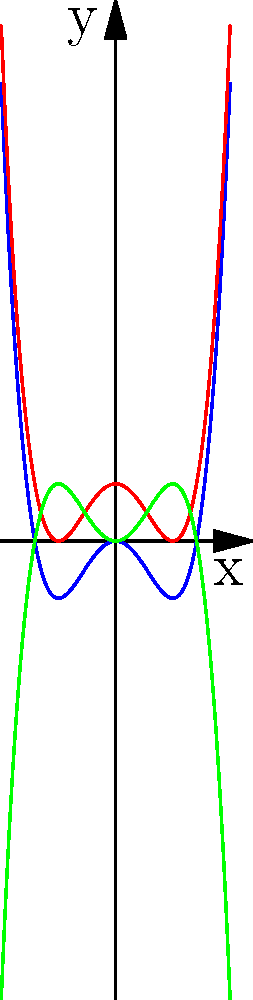As an NLP developer working on language models, you're exploring mathematical concepts to enhance your model's understanding. Consider the quartic polynomial $f(x) = x^4 - 2x^2$ and its transformations $g(x) = x^4 - 2x^2 + 1$ and $h(x) = -x^4 + 2x^2$. How do these transformations affect the graph's key features, such as y-intercepts, local extrema, and end behavior? Describe the changes in relation to the original function $f(x)$. Let's analyze each function step-by-step:

1. Original function $f(x) = x^4 - 2x^2$:
   - Y-intercept: $f(0) = 0$
   - Local extrema: Minimum at $(0,0)$, local maxima at $(\pm 1, -1)$
   - End behavior: As $x \to \pm\infty$, $f(x) \to +\infty$

2. Vertical shift $g(x) = x^4 - 2x^2 + 1$:
   - Y-intercept: $g(0) = 1$ (shifted up by 1 unit)
   - Local extrema: Minimum at $(0,1)$, local maxima at $(\pm 1, 0)$
   - End behavior: Same as $f(x)$, but the entire graph is shifted up by 1 unit

3. Reflection $h(x) = -x^4 + 2x^2$:
   - Y-intercept: $h(0) = 0$ (same as original)
   - Local extrema: Maximum at $(0,0)$, local minima at $(\pm 1, 1)$
   - End behavior: As $x \to \pm\infty$, $h(x) \to -\infty$ (opposite of $f(x)$)

Key changes:
1. Vertical shift ($g(x)$) moves the entire graph up by 1 unit, affecting y-intercept and extrema points.
2. Reflection ($h(x)$) flips the graph vertically, changing local maxima to minima and vice versa, and inverting the end behavior.
Answer: Vertical shift: +1 unit up. Reflection: Vertical flip, inverted extrema and end behavior. 